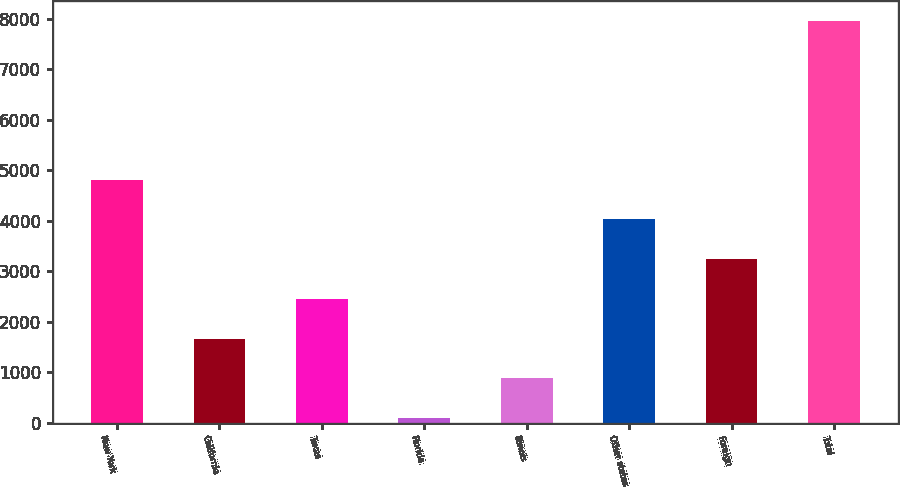Convert chart to OTSL. <chart><loc_0><loc_0><loc_500><loc_500><bar_chart><fcel>New York<fcel>California<fcel>Texas<fcel>Florida<fcel>Illinois<fcel>Other states<fcel>Foreign<fcel>Total<nl><fcel>4816<fcel>1668<fcel>2455<fcel>94<fcel>881<fcel>4029<fcel>3242<fcel>7964<nl></chart> 